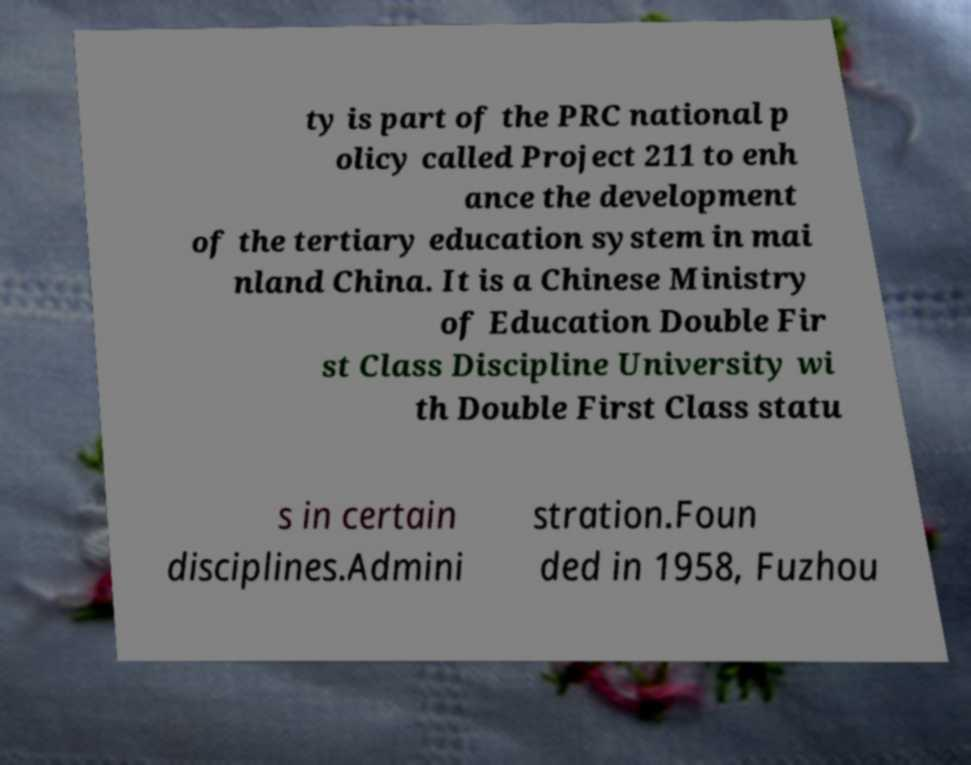Can you accurately transcribe the text from the provided image for me? ty is part of the PRC national p olicy called Project 211 to enh ance the development of the tertiary education system in mai nland China. It is a Chinese Ministry of Education Double Fir st Class Discipline University wi th Double First Class statu s in certain disciplines.Admini stration.Foun ded in 1958, Fuzhou 